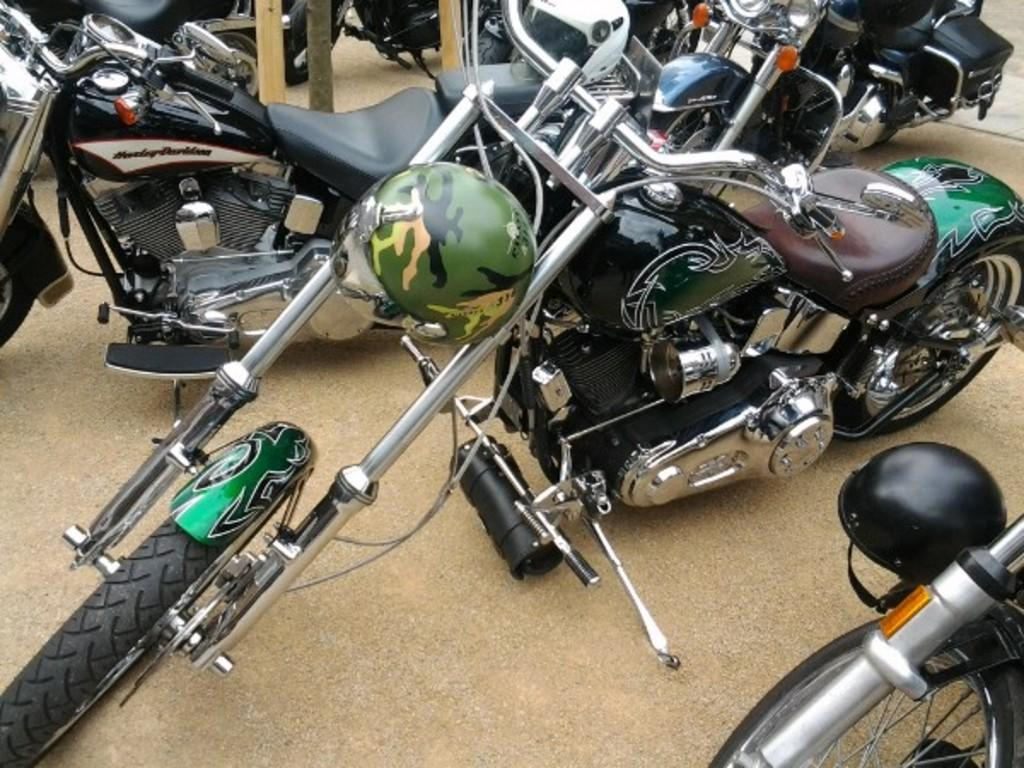What type of vehicles are in the image? There is a group of motorcycles in the image. How are the motorcycles positioned in the image? The motorcycles are parked on the ground. What safety gear is visible in the image? There is a helmet on the right side of the image. What type of structures can be seen at the top of the image? There are wooden poles visible at the top of the image. What type of jewel can be seen glowing in the image? There is no jewel present in the image; it features a group of parked motorcycles, a helmet, and wooden poles. What type of current is flowing through the motorcycles in the image? There is no indication of electrical current in the image; the motorcycles are parked and not in use. 